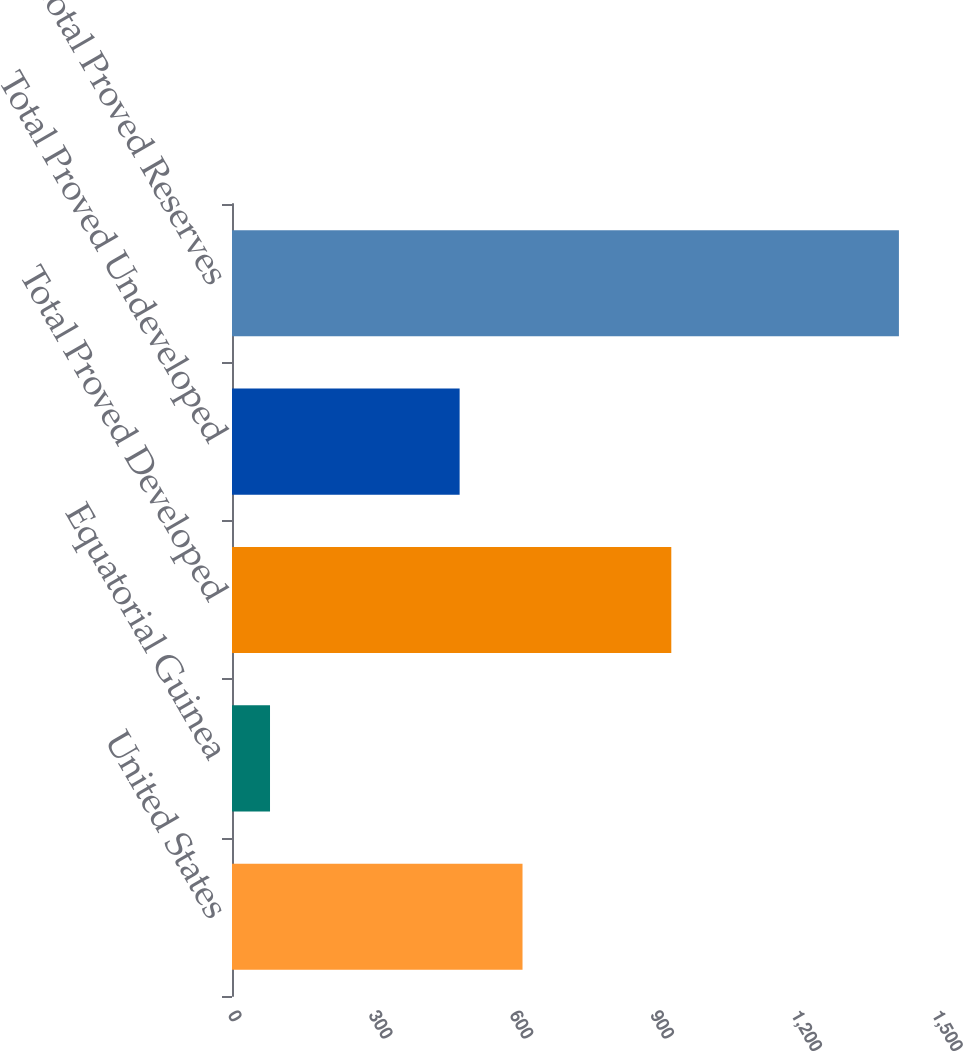Convert chart to OTSL. <chart><loc_0><loc_0><loc_500><loc_500><bar_chart><fcel>United States<fcel>Equatorial Guinea<fcel>Total Proved Developed<fcel>Total Proved Undeveloped<fcel>Total Proved Reserves<nl><fcel>619<fcel>81<fcel>936<fcel>485<fcel>1421<nl></chart> 